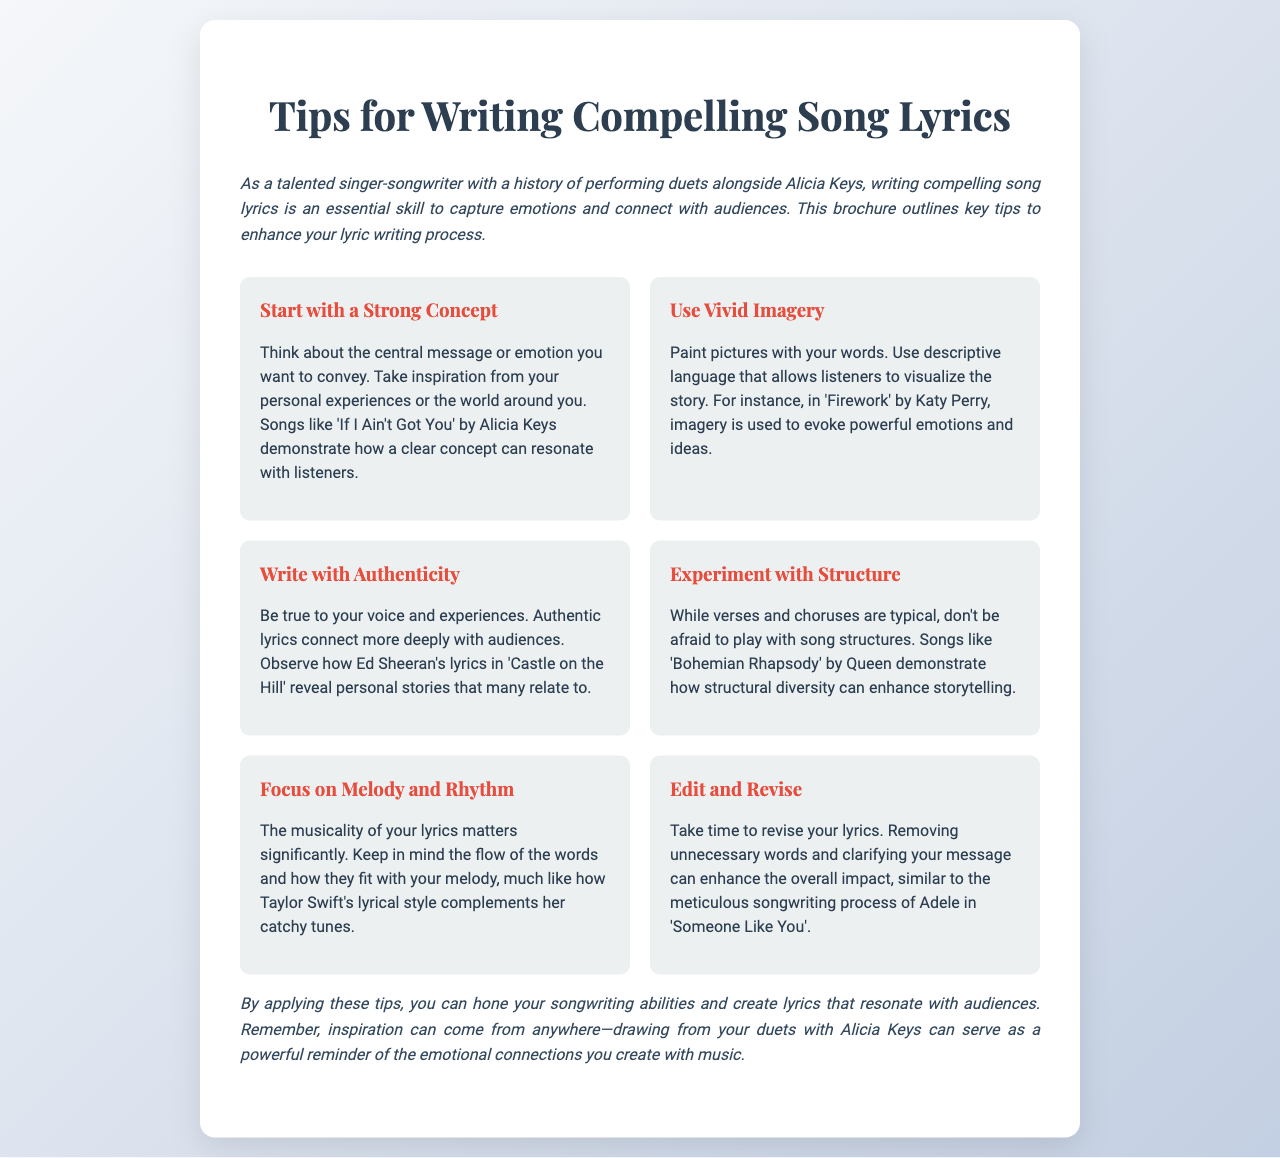What is the title of the brochure? The title is prominently displayed at the top of the document.
Answer: Tips for Writing Compelling Song Lyrics Who is mentioned as a performer in the introduction? The introduction references a specific artist known for performing with the author.
Answer: Alicia Keys What is the first tip for writing song lyrics? The first tip is clearly indicated in the tips section of the document.
Answer: Start with a Strong Concept Which song is referenced to illustrate vivid imagery? A specific song is cited to highlight the use of imagery in lyrics.
Answer: Firework Who is noted for writing with authenticity? The document includes a reference to a specific artist known for authentic lyrics.
Answer: Ed Sheeran What structural aspect is encouraged for songwriting? The document advises a particular approach to song structure.
Answer: Experiment with Structure What does the fifth tip emphasize regarding lyrics? The fifth tip discusses an important element of lyrical composition.
Answer: Focus on Melody and Rhythm What is suggested for the revision process? The document provides guidance on improving lyrics through a specific action.
Answer: Edit and Revise What emotional aspect is mentioned in the closing? The closing paragraph touches on a particular emotional connection in songwriting.
Answer: Emotional connections 